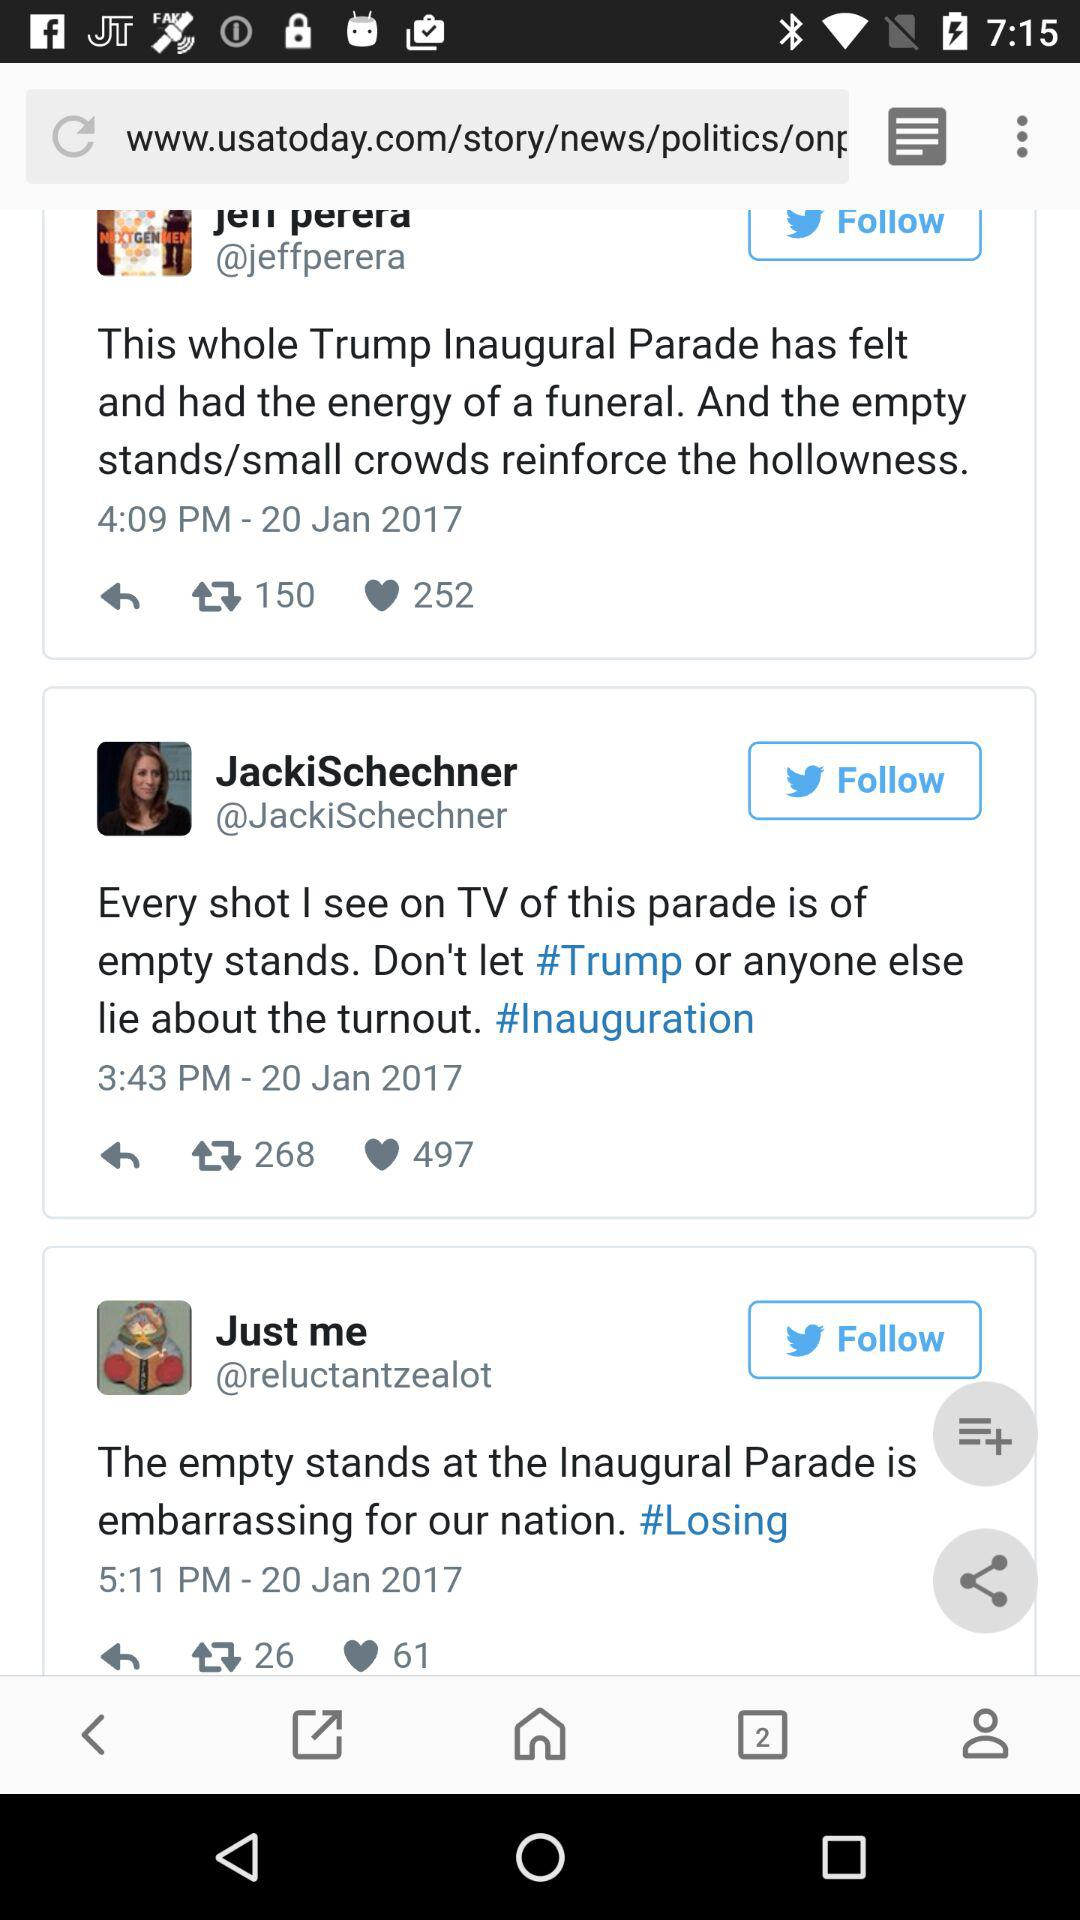On what date were all posts posted? All posts were posted on January 20, 2017. 